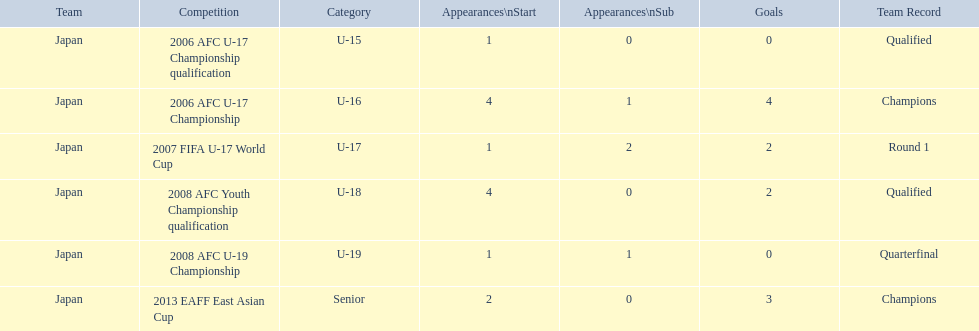In each competition, what is the number of appearances? 1, 4, 1, 4, 1, 2. How many goals were scored in each competition? 0, 4, 2, 2, 0, 3. Which competition has the highest number of appearances? 2006 AFC U-17 Championship, 2008 AFC Youth Championship qualification. Which competition has the highest number of goals? 2006 AFC U-17 Championship. 